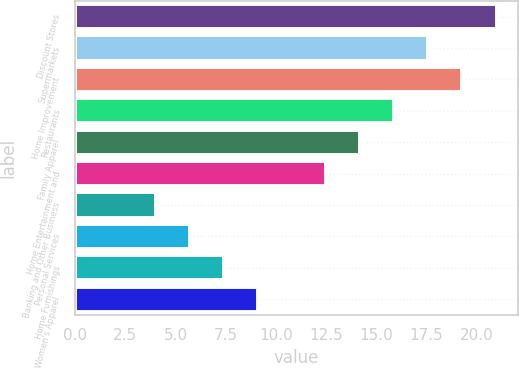<chart> <loc_0><loc_0><loc_500><loc_500><bar_chart><fcel>Discount Stores<fcel>Supermarkets<fcel>Home Improvement<fcel>Restaurants<fcel>Family Apparel<fcel>Home Entertainment and<fcel>Banking and Other Business<fcel>Personal Services<fcel>Home Furnishings<fcel>Women's Apparel<nl><fcel>21<fcel>17.6<fcel>19.3<fcel>15.9<fcel>14.2<fcel>12.5<fcel>4<fcel>5.7<fcel>7.4<fcel>9.1<nl></chart> 